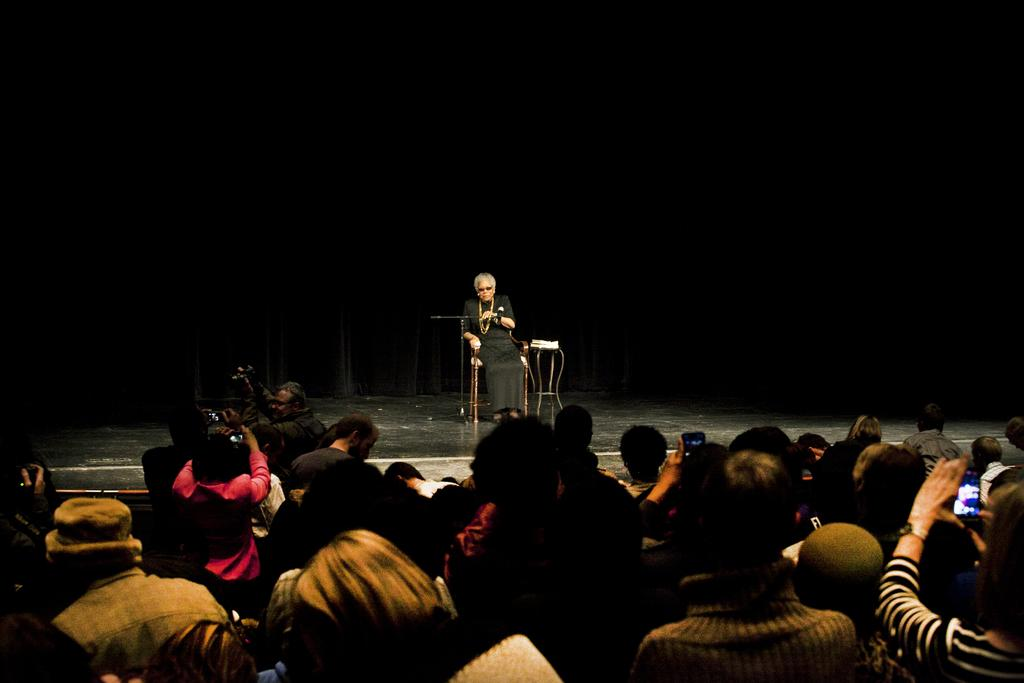Who is the main subject in the image? There is an old man in the image. Where is the old man located? The old man is on a stage. What is the old man doing on the stage? The old man is sitting on a chair. What type of brush is the old man using to create a painting in the image? There is no brush or painting present in the image; the old man is simply sitting on a chair on the stage. 